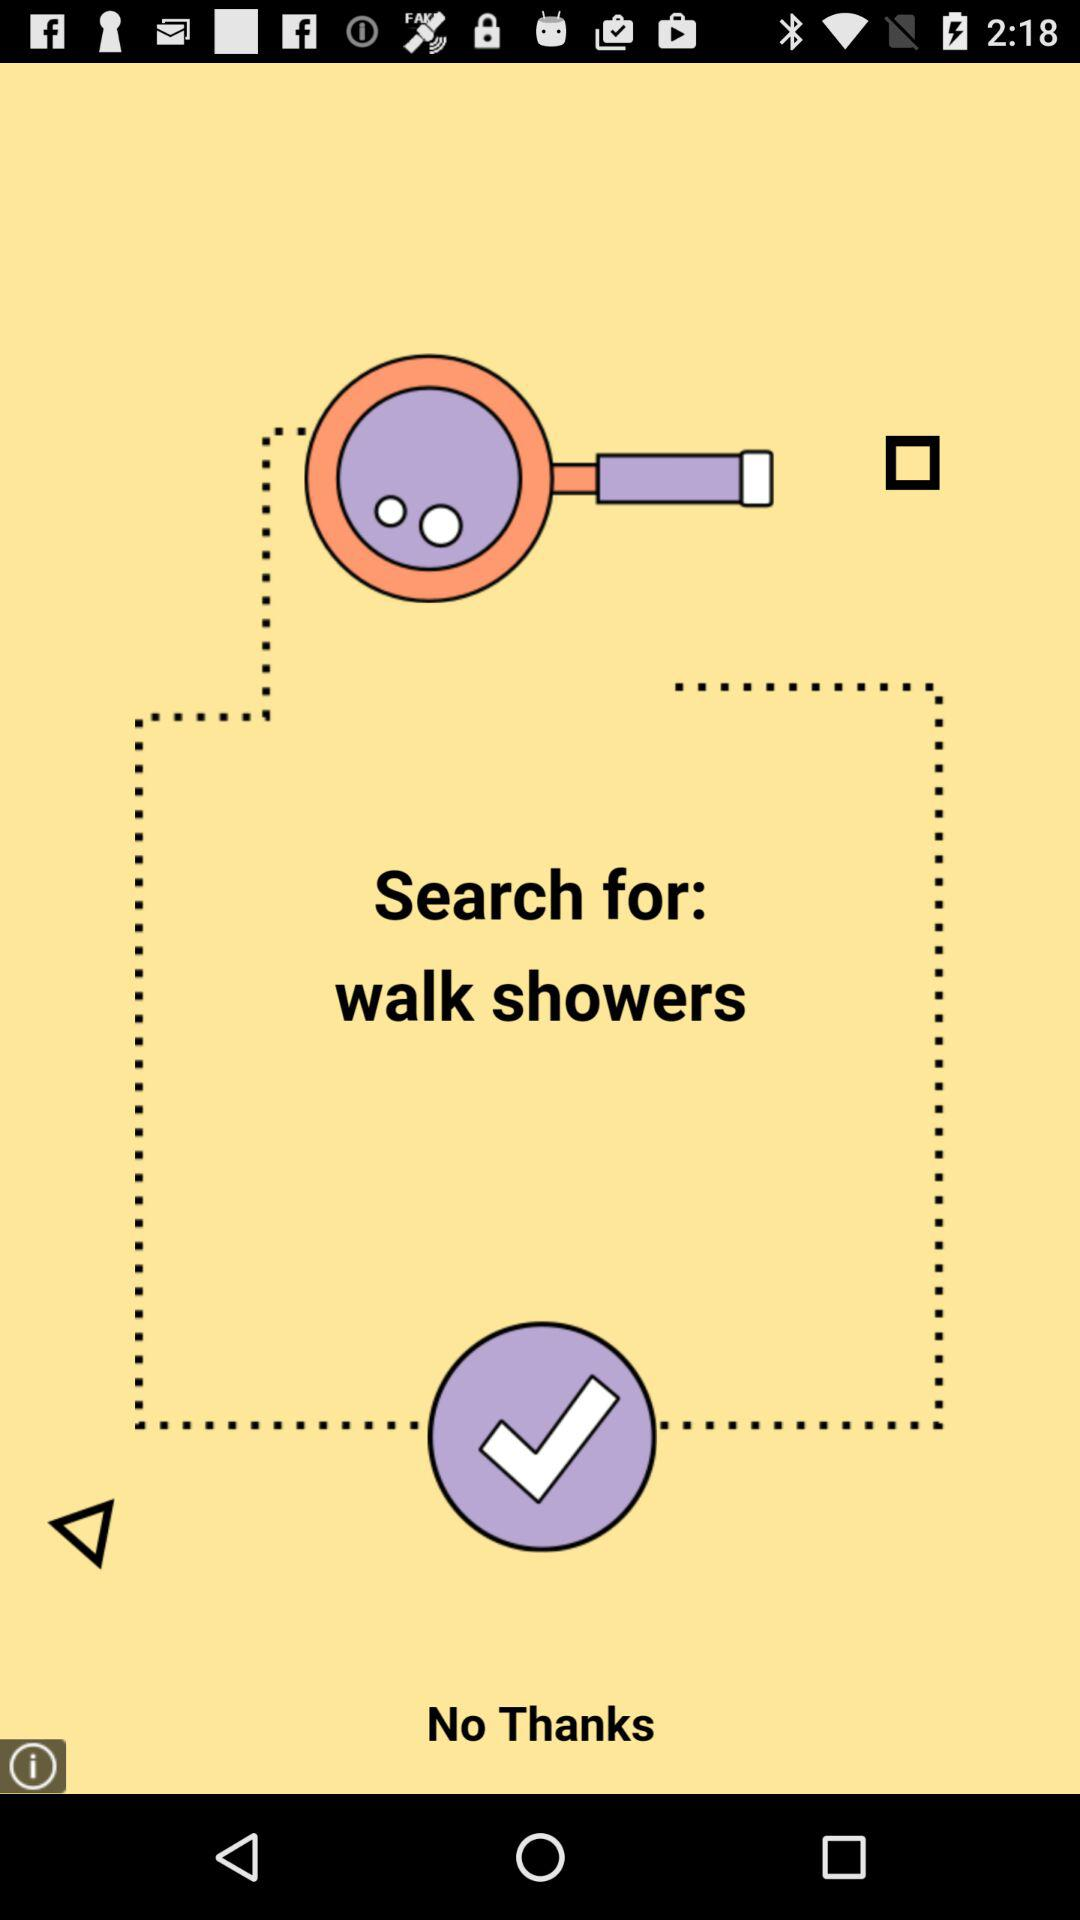What is to be searched for? The term that is to be searched for is "walk showers". 